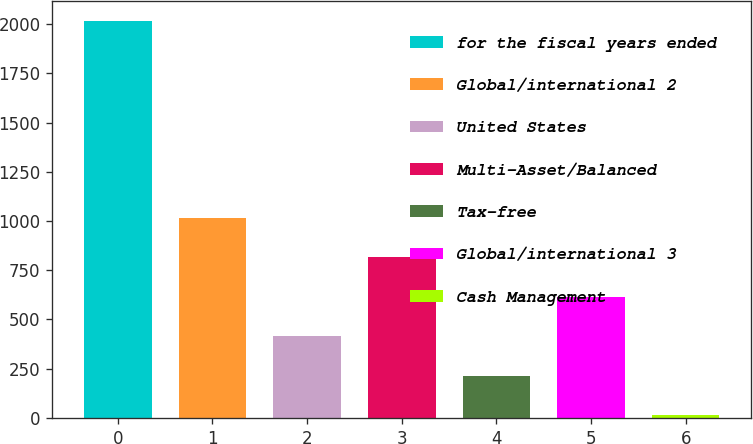Convert chart to OTSL. <chart><loc_0><loc_0><loc_500><loc_500><bar_chart><fcel>for the fiscal years ended<fcel>Global/international 2<fcel>United States<fcel>Multi-Asset/Balanced<fcel>Tax-free<fcel>Global/international 3<fcel>Cash Management<nl><fcel>2017<fcel>1016<fcel>415.4<fcel>815.8<fcel>215.2<fcel>615.6<fcel>15<nl></chart> 